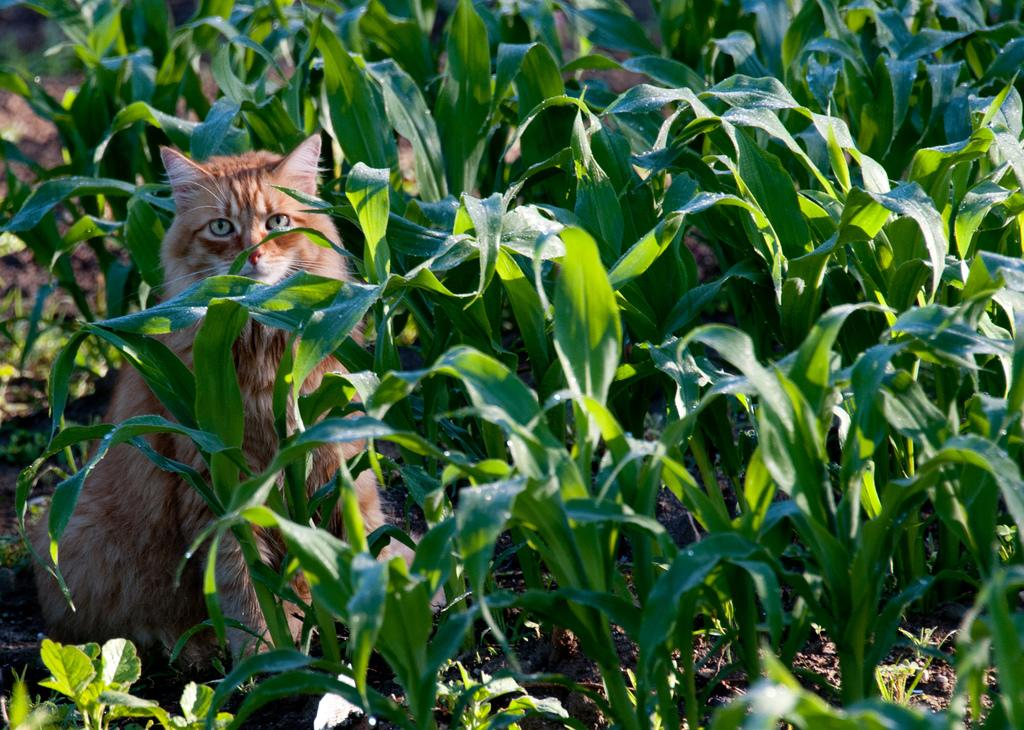What type of animal is in the image? There is a cat in the image. Can you describe the cat's surroundings? The cat is sitting between green plants. What type of company is the cat working for in the image? There is no indication in the image that the cat is working for a company. 